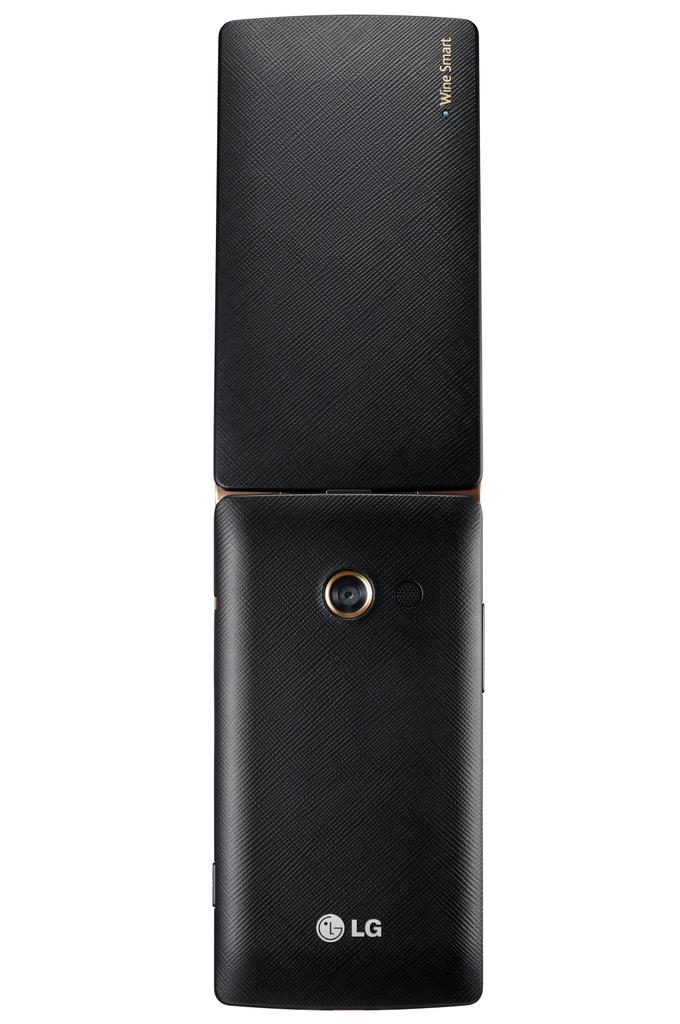Provide a one-sentence caption for the provided image. The device has LG branding along with the words Wine Smart. 